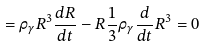<formula> <loc_0><loc_0><loc_500><loc_500>= \rho _ { \gamma } R ^ { 3 } \frac { d R } { d t } - R \frac { 1 } { 3 } \rho _ { \gamma } \frac { d } { d t } R ^ { 3 } = 0</formula> 